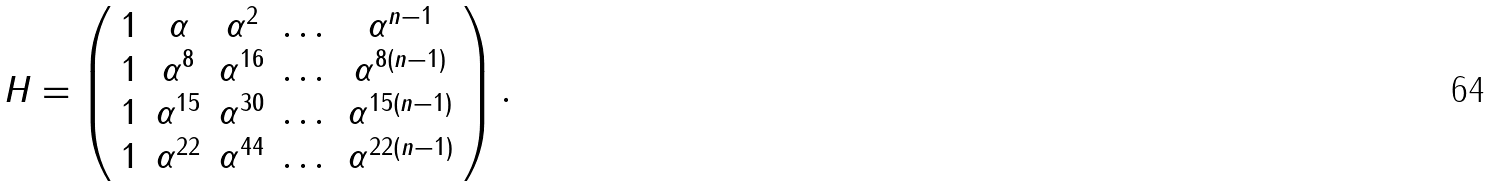<formula> <loc_0><loc_0><loc_500><loc_500>H = \left ( \begin{array} { c c c c c } 1 & \alpha & \alpha ^ { 2 } & \dots & \alpha ^ { n - 1 } \\ 1 & \alpha ^ { 8 } & \alpha ^ { 1 6 } & \dots & \alpha ^ { 8 ( n - 1 ) } \\ 1 & \alpha ^ { 1 5 } & \alpha ^ { 3 0 } & \dots & \alpha ^ { 1 5 ( n - 1 ) } \\ 1 & \alpha ^ { 2 2 } & \alpha ^ { 4 4 } & \dots & \alpha ^ { 2 2 \left ( n - 1 \right ) } \end{array} \right ) .</formula> 